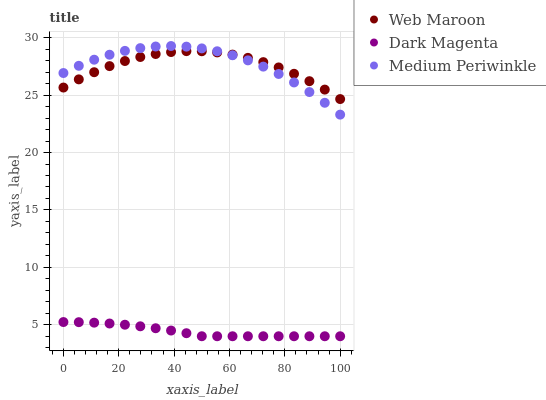Does Dark Magenta have the minimum area under the curve?
Answer yes or no. Yes. Does Medium Periwinkle have the maximum area under the curve?
Answer yes or no. Yes. Does Web Maroon have the minimum area under the curve?
Answer yes or no. No. Does Web Maroon have the maximum area under the curve?
Answer yes or no. No. Is Dark Magenta the smoothest?
Answer yes or no. Yes. Is Medium Periwinkle the roughest?
Answer yes or no. Yes. Is Web Maroon the smoothest?
Answer yes or no. No. Is Web Maroon the roughest?
Answer yes or no. No. Does Dark Magenta have the lowest value?
Answer yes or no. Yes. Does Web Maroon have the lowest value?
Answer yes or no. No. Does Medium Periwinkle have the highest value?
Answer yes or no. Yes. Does Web Maroon have the highest value?
Answer yes or no. No. Is Dark Magenta less than Medium Periwinkle?
Answer yes or no. Yes. Is Medium Periwinkle greater than Dark Magenta?
Answer yes or no. Yes. Does Medium Periwinkle intersect Web Maroon?
Answer yes or no. Yes. Is Medium Periwinkle less than Web Maroon?
Answer yes or no. No. Is Medium Periwinkle greater than Web Maroon?
Answer yes or no. No. Does Dark Magenta intersect Medium Periwinkle?
Answer yes or no. No. 